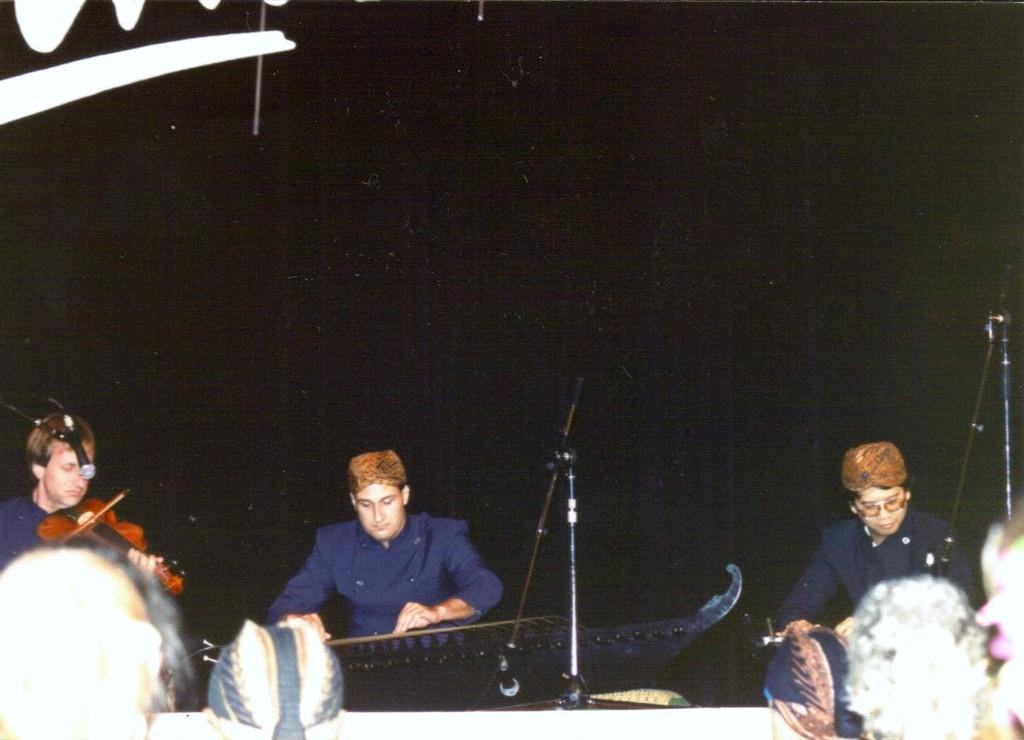Can you describe this image briefly? 3 people are sitting on the stage and playing musical instruments. the person at the left is playing a brown violin. they are wearing blue dress and a cap. in front of them there are microphones. in the front people are watching them. behind them there is black background. 